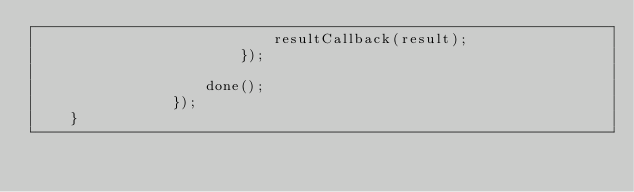<code> <loc_0><loc_0><loc_500><loc_500><_JavaScript_>                            resultCallback(result);
                        });
                    
                    done();
                });
    }
  </code> 